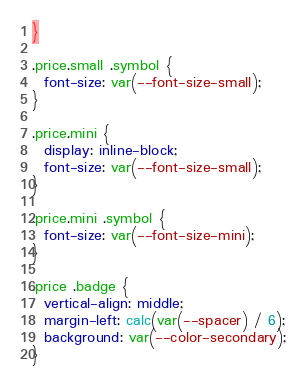Convert code to text. <code><loc_0><loc_0><loc_500><loc_500><_CSS_>}

.price.small .symbol {
  font-size: var(--font-size-small);
}

.price.mini {
  display: inline-block;
  font-size: var(--font-size-small);
}

.price.mini .symbol {
  font-size: var(--font-size-mini);
}

.price .badge {
  vertical-align: middle;
  margin-left: calc(var(--spacer) / 6);
  background: var(--color-secondary);
}
</code> 